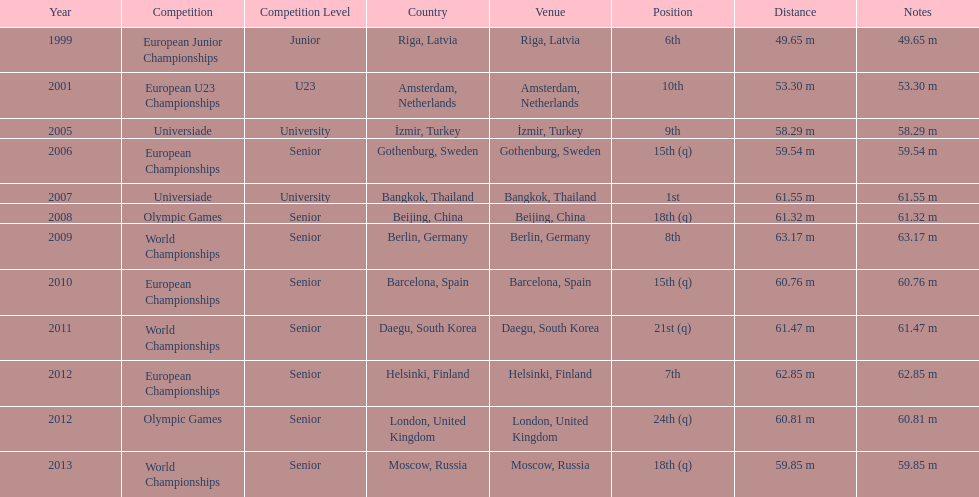What are the years listed prior to 2007? 1999, 2001, 2005, 2006. What are their corresponding finishes? 6th, 10th, 9th, 15th (q). Which is the highest? 6th. 